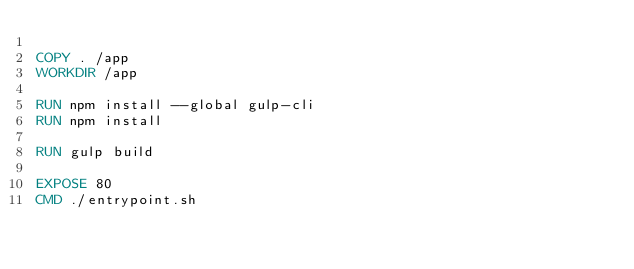<code> <loc_0><loc_0><loc_500><loc_500><_Dockerfile_>
COPY . /app
WORKDIR /app

RUN npm install --global gulp-cli
RUN npm install

RUN gulp build

EXPOSE 80
CMD ./entrypoint.sh</code> 